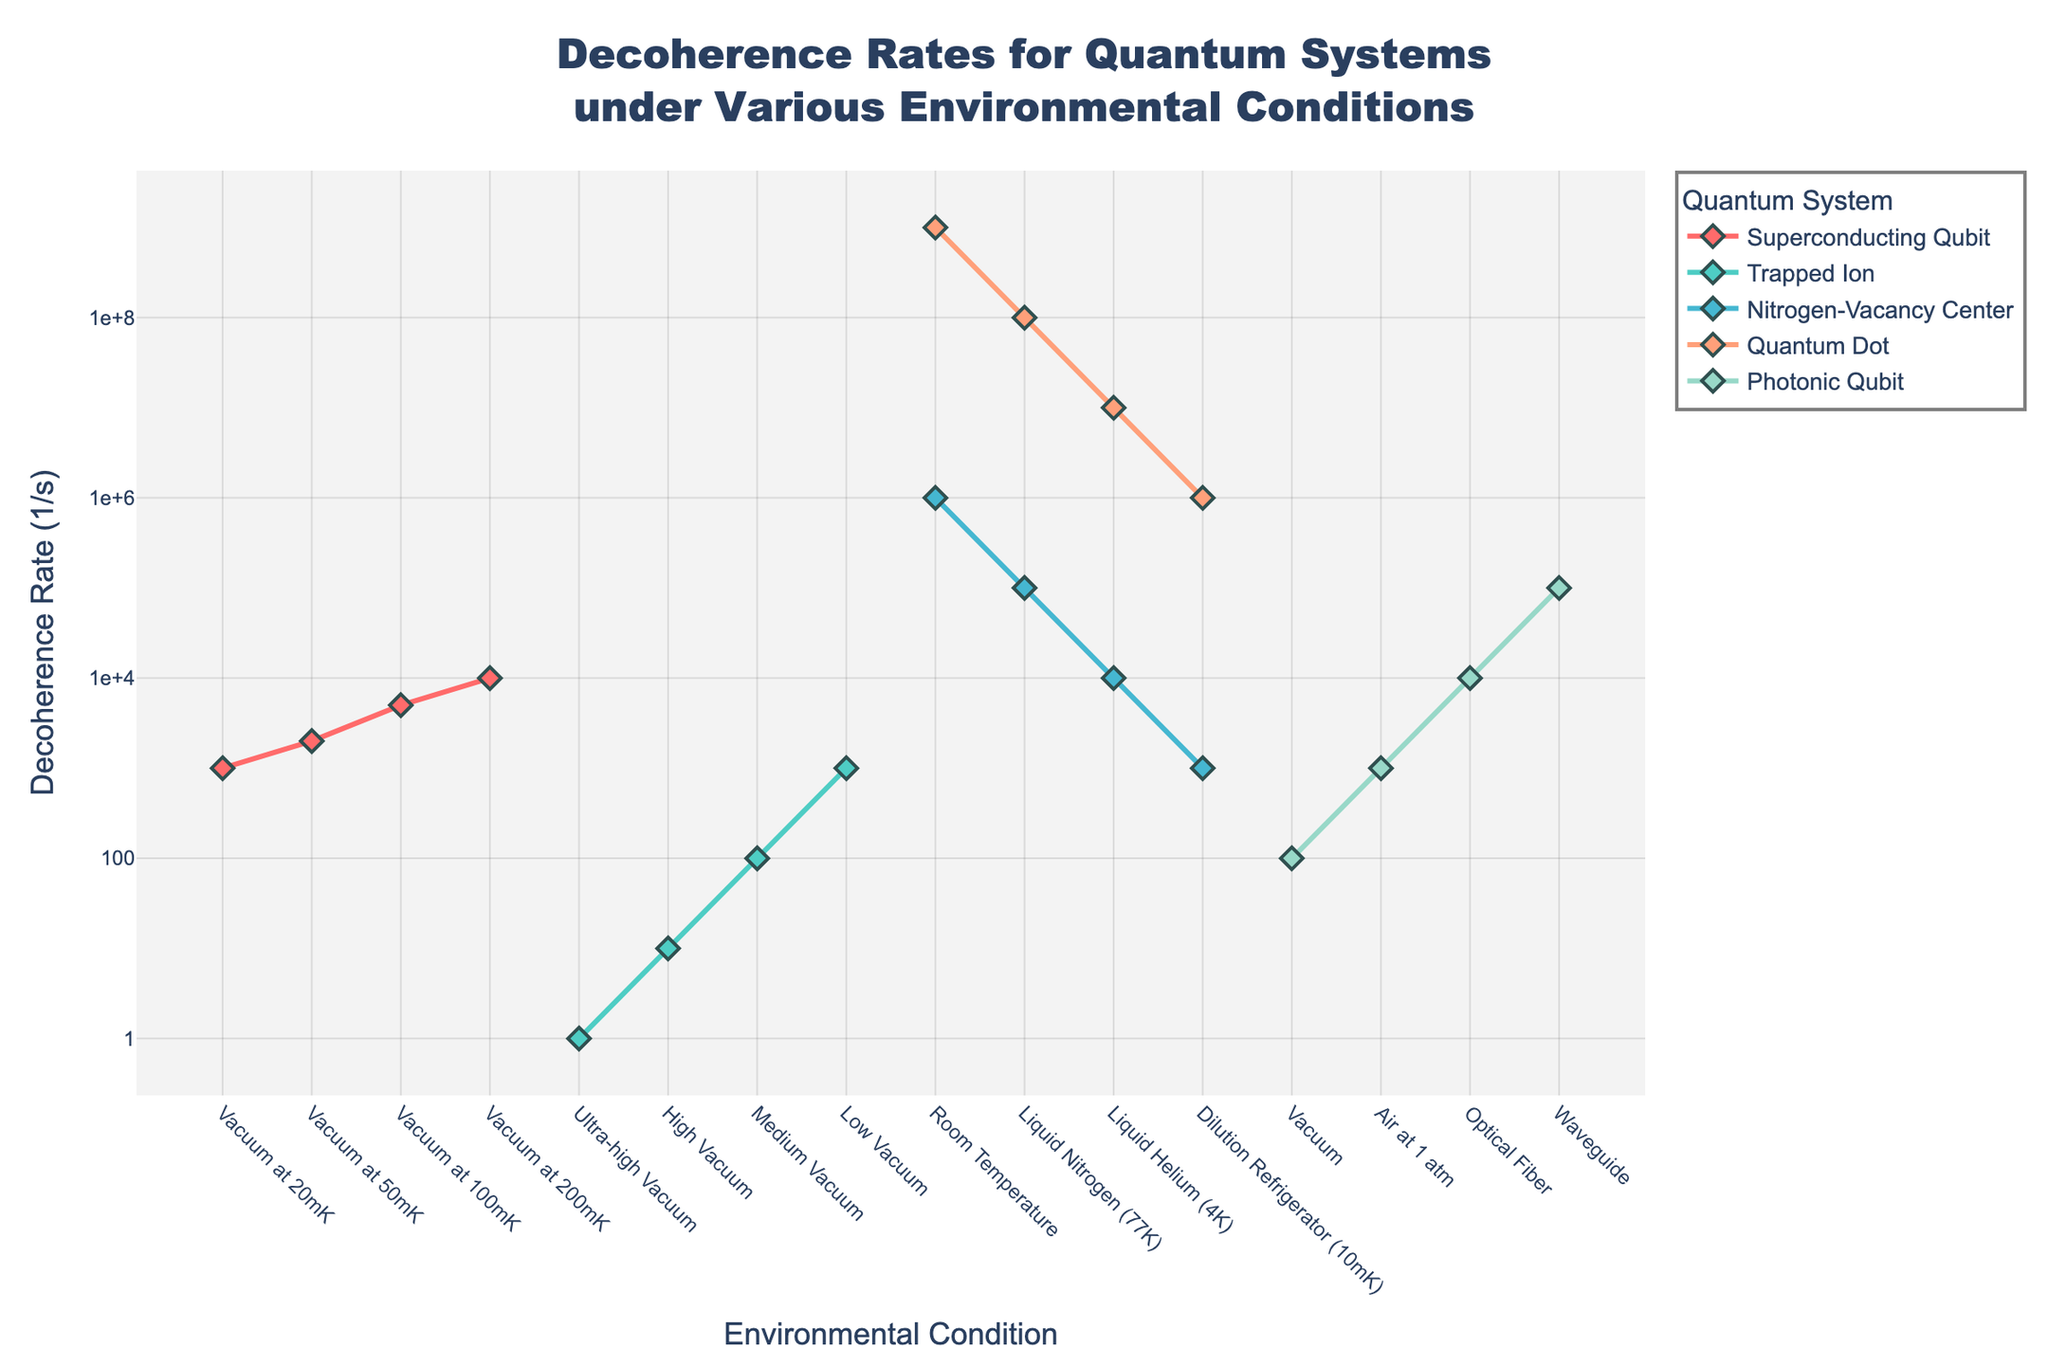what system shows the lowest decoherence rate overall? By looking at the plot, one can see which line trace appears lowest on the y-axis, indicating the minimal decoherence rate. The 'Trapped Ion' system exhibits the lowest decoherence rate under 'Ultra-high Vacuum' conditions, appearing at the bottommost part of the graph.
Answer: 'Trapped Ion' how does the decoherence rate of the superconducting qubit change as the temperature increases from 20mK to 200mK? The plot shows the 'Superconducting Qubit' decoherence rate increasing as the temperature goes up. At 20mK, it is 1e3 (1,000 1/s), rising to 2e3 (2,000 1/s) at 50mK, 5e3 (5,000 1/s) at 100mK, and eventually reaching 1e4 (10,000 1/s) at 200mK.
Answer: It increases from 1e3 to 1e4 which quantum system exhibits the steepest increase in decoherence rate under varying environmental conditions? To determine the steepest increase, observe the slope of each line trace. The 'Quantum Dot' system demonstrates a steep rise, moving from 1e6 (10mK) to 1e9 (Room Temperature), indicating a significant change.
Answer: 'Quantum Dot' is the decoherence rate for nitrogen-vacancy center at room temperature higher or lower than that for superconducting qubit at 200mK? Comparing their positions directly on the plot, the 'Nitrogen-Vacancy Center' (Room Temperature) is at 1e6, and 'Superconducting Qubit' (200mK) is lower at 1e4. Hence, the decoherence rate for the former is higher.
Answer: Higher what is the difference in decoherence rates between quantum dot at room temperature and photonic qubit in an optical fiber? By examining the figure, the 'Quantum Dot' (Room Temperature) rate is 1e9, while the 'Photonic Qubit' (Optical Fiber) rate is 1e4. The difference is obtained by subtracting these values: 1e9 - 1e4 = 999,990,000.
Answer: 999,990,000 which environmental condition demonstrates the highest decoherence rate for the photonic qubit? Observing the y-axis values associated with each environmental condition for the 'Photonic Qubit', the 'Waveguide' condition shows the highest rate at 1e5 (100,000 1/s).
Answer: 'Waveguide' if the nitrogen-vacancy center in a dilution refrigerator had a decoherence rate between the rates observed for the superconducting qubit at 50mK and 100mK conditions, would it be higher or lower? From the graph, the 'Superconducting Qubit' at 50mK has a rate of 2e3, and at 100mK, it has a rate of 5e3. The 'Nitrogen-Vacancy Center' (Dilution Refrigerator) has a rate of 1e3. Since 1e3 lies below both 2e3 and 5e3, it would be lower.
Answer: Lower which system has a more consistent decoherence rate across different conditions, trapped ion or quantum dot? Evaluating the consistency involves assessing the variance in the y-axis positions. 'Trapped Ion' generally remains in the range 1e0 to 1e3, showing less variance, while 'Quantum Dot' shifts considerably between 1e6 and 1e9. Thus, 'Trapped Ion' is more consistent.
Answer: 'Trapped Ion' how does the decoherence rate of nitrogen-vacancy center compare between liquid nitrogen and liquid helium conditions? On the chart, the 'Nitrogen-Vacancy Center' in Liquid Nitrogen (77K) has a rate of 1e5, whereas in Liquid Helium (4K), it's 1e4. Comparing these, the rate in Liquid Nitrogen is higher than in Liquid Helium.
Answer: Higher 